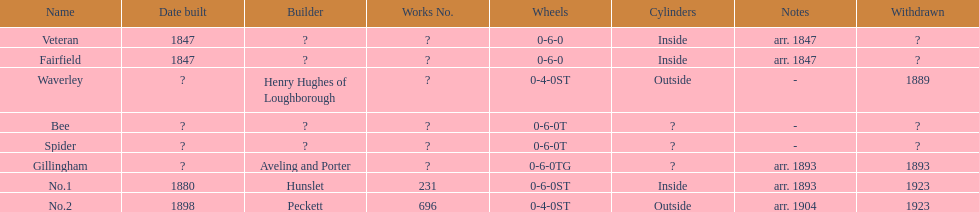Parse the full table. {'header': ['Name', 'Date built', 'Builder', 'Works No.', 'Wheels', 'Cylinders', 'Notes', 'Withdrawn'], 'rows': [['Veteran', '1847', '?', '?', '0-6-0', 'Inside', 'arr. 1847', '?'], ['Fairfield', '1847', '?', '?', '0-6-0', 'Inside', 'arr. 1847', '?'], ['Waverley', '?', 'Henry Hughes of Loughborough', '?', '0-4-0ST', 'Outside', '-', '1889'], ['Bee', '?', '?', '?', '0-6-0T', '?', '-', '?'], ['Spider', '?', '?', '?', '0-6-0T', '?', '-', '?'], ['Gillingham', '?', 'Aveling and Porter', '?', '0-6-0TG', '?', 'arr. 1893', '1893'], ['No.1', '1880', 'Hunslet', '231', '0-6-0ST', 'Inside', 'arr. 1893', '1923'], ['No.2', '1898', 'Peckett', '696', '0-4-0ST', 'Outside', 'arr. 1904', '1923']]} What is the total number of names on the chart? 8. 